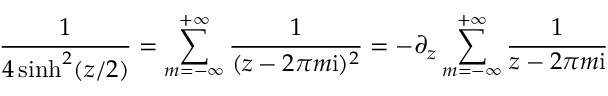<formula> <loc_0><loc_0><loc_500><loc_500>\frac { 1 } { 4 \sinh ^ { 2 } ( z / 2 ) } = \sum _ { m = - \infty } ^ { + \infty } \frac { 1 } { ( z - 2 \pi m i ) ^ { 2 } } = - \partial _ { z } \sum _ { m = - \infty } ^ { + \infty } \frac { 1 } { z - 2 \pi m i }</formula> 